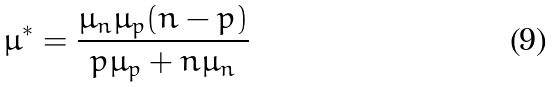Convert formula to latex. <formula><loc_0><loc_0><loc_500><loc_500>\mu ^ { * } = \frac { \mu _ { n } \mu _ { p } ( n - p ) } { p \mu _ { p } + n \mu _ { n } }</formula> 